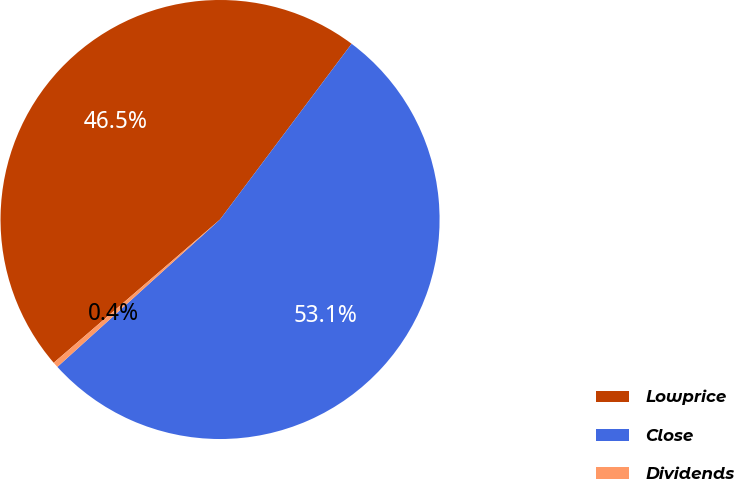Convert chart to OTSL. <chart><loc_0><loc_0><loc_500><loc_500><pie_chart><fcel>Lowprice<fcel>Close<fcel>Dividends<nl><fcel>46.55%<fcel>53.06%<fcel>0.4%<nl></chart> 